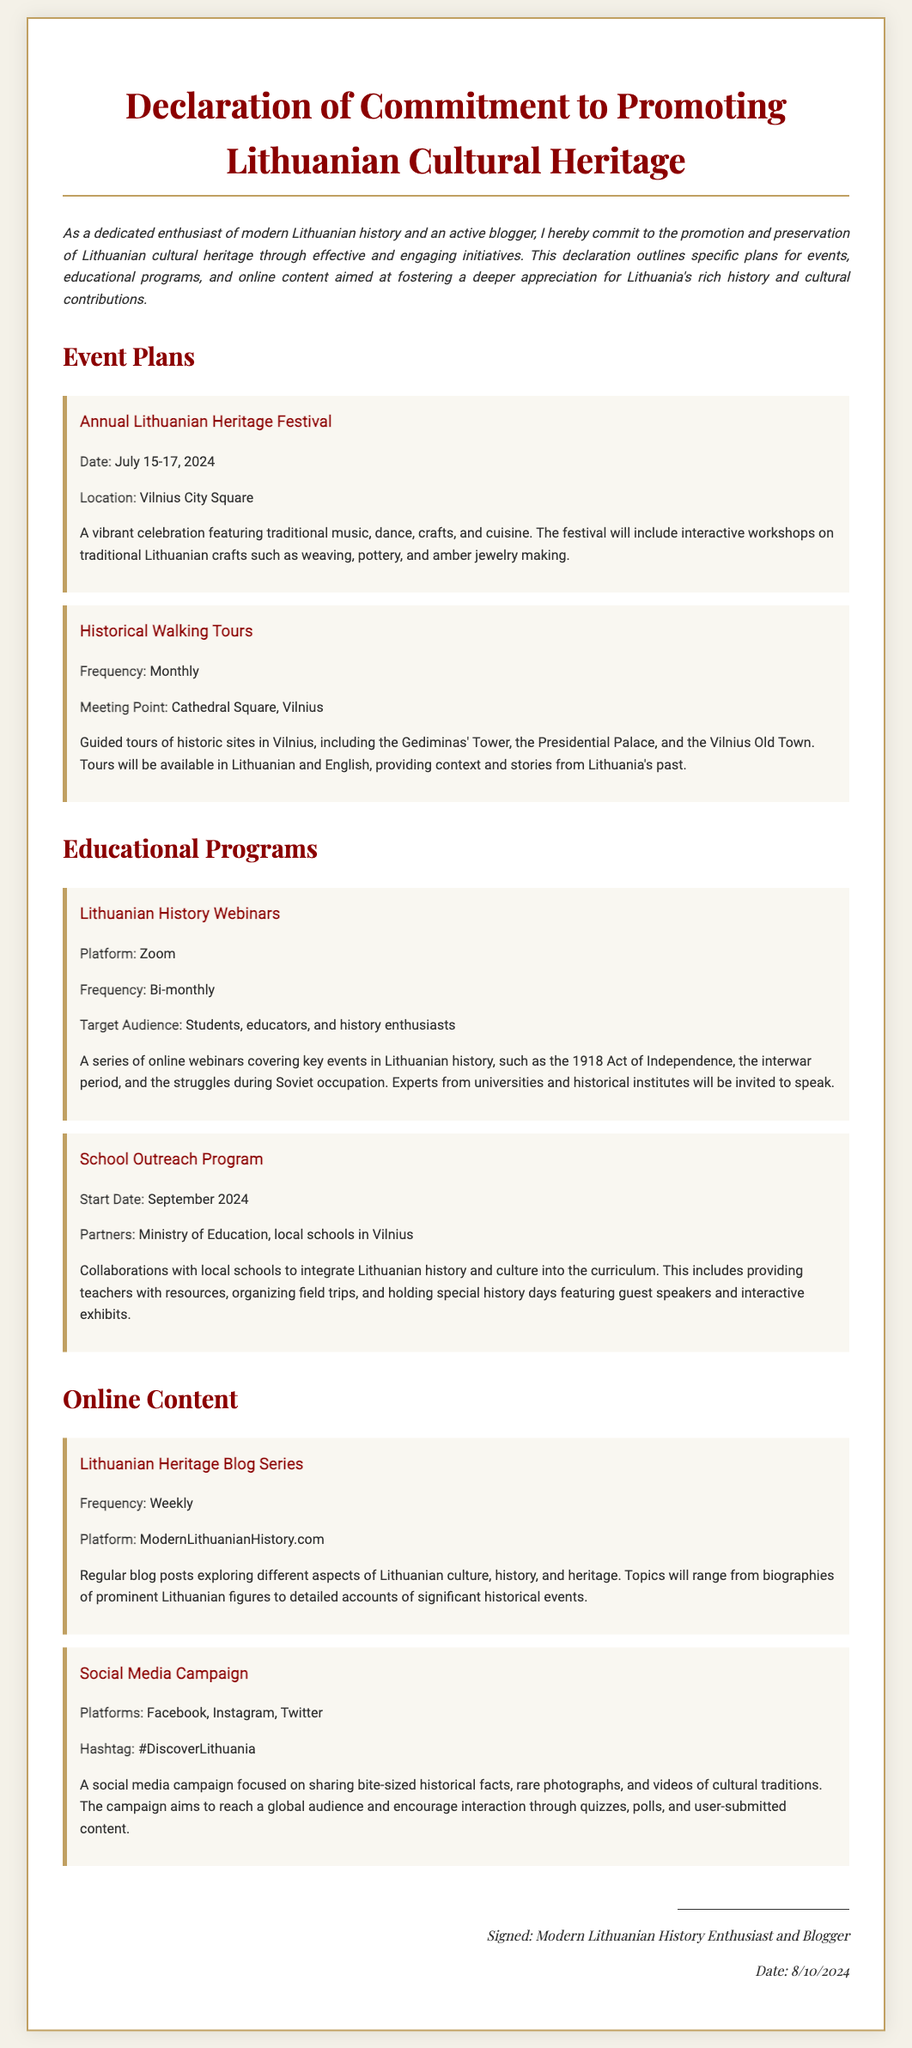What is the title of the document? The title of the document is stated at the top, indicating the purpose of the commitment.
Answer: Declaration of Commitment to Promoting Lithuanian Cultural Heritage What are the dates for the Annual Lithuanian Heritage Festival? The document specifies the exact dates for the event in July 2024.
Answer: July 15-17, 2024 Where will the Annual Lithuanian Heritage Festival take place? The location for the festival is mentioned within the event plans.
Answer: Vilnius City Square What is the frequency of the Lithuanian History Webinars? The document provides information about how often the webinars are scheduled.
Answer: Bi-monthly Which social media platforms are used for the Social Media Campaign? The platforms for the campaign are explicitly listed in the document.
Answer: Facebook, Instagram, Twitter What is the target audience for the School Outreach Program? The audience for the program is specified in the educational programs section.
Answer: Local schools in Vilnius How many historical walking tours are conducted in a month? The document states the frequency of these tours clearly.
Answer: Monthly What is the hashtag used for the Social Media Campaign? The document mentions this hashtag for raising awareness about Lithuanian heritage.
Answer: #DiscoverLithuania 